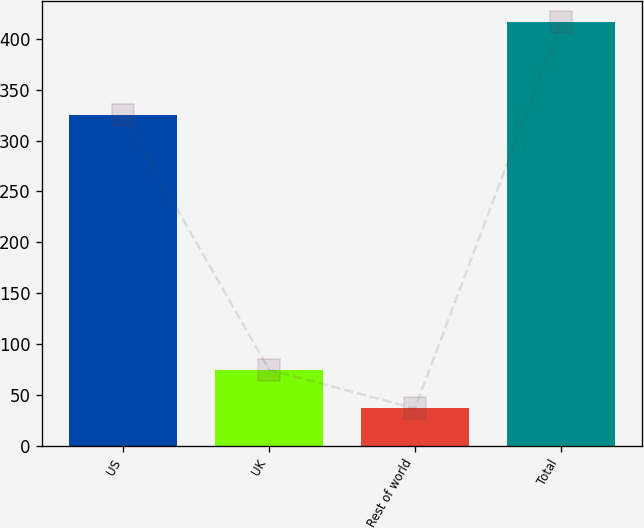<chart> <loc_0><loc_0><loc_500><loc_500><bar_chart><fcel>US<fcel>UK<fcel>Rest of world<fcel>Total<nl><fcel>324.9<fcel>74.56<fcel>36.6<fcel>416.2<nl></chart> 